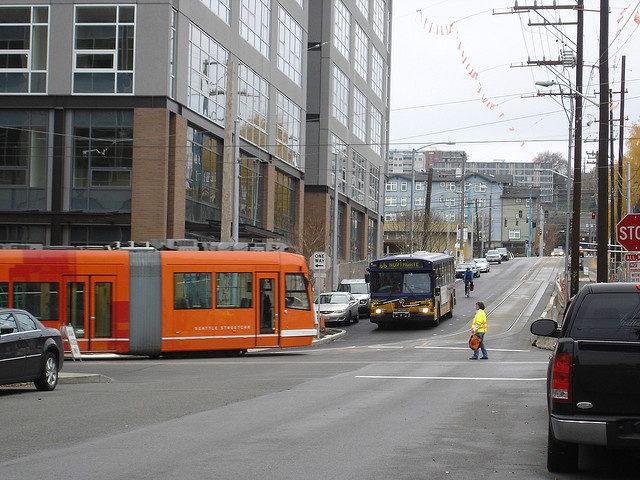Describe the objects in this image and their specific colors. I can see bus in gray, red, brown, and black tones, train in gray, red, black, and brown tones, car in gray, black, and darkgray tones, bus in gray, black, darkgray, and olive tones, and car in gray, black, and darkgray tones in this image. 